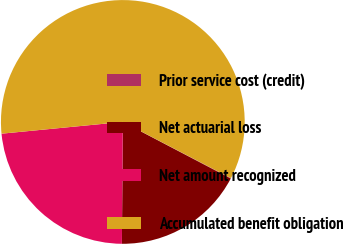Convert chart to OTSL. <chart><loc_0><loc_0><loc_500><loc_500><pie_chart><fcel>Prior service cost (credit)<fcel>Net actuarial loss<fcel>Net amount recognized<fcel>Accumulated benefit obligation<nl><fcel>0.06%<fcel>17.43%<fcel>23.34%<fcel>59.17%<nl></chart> 